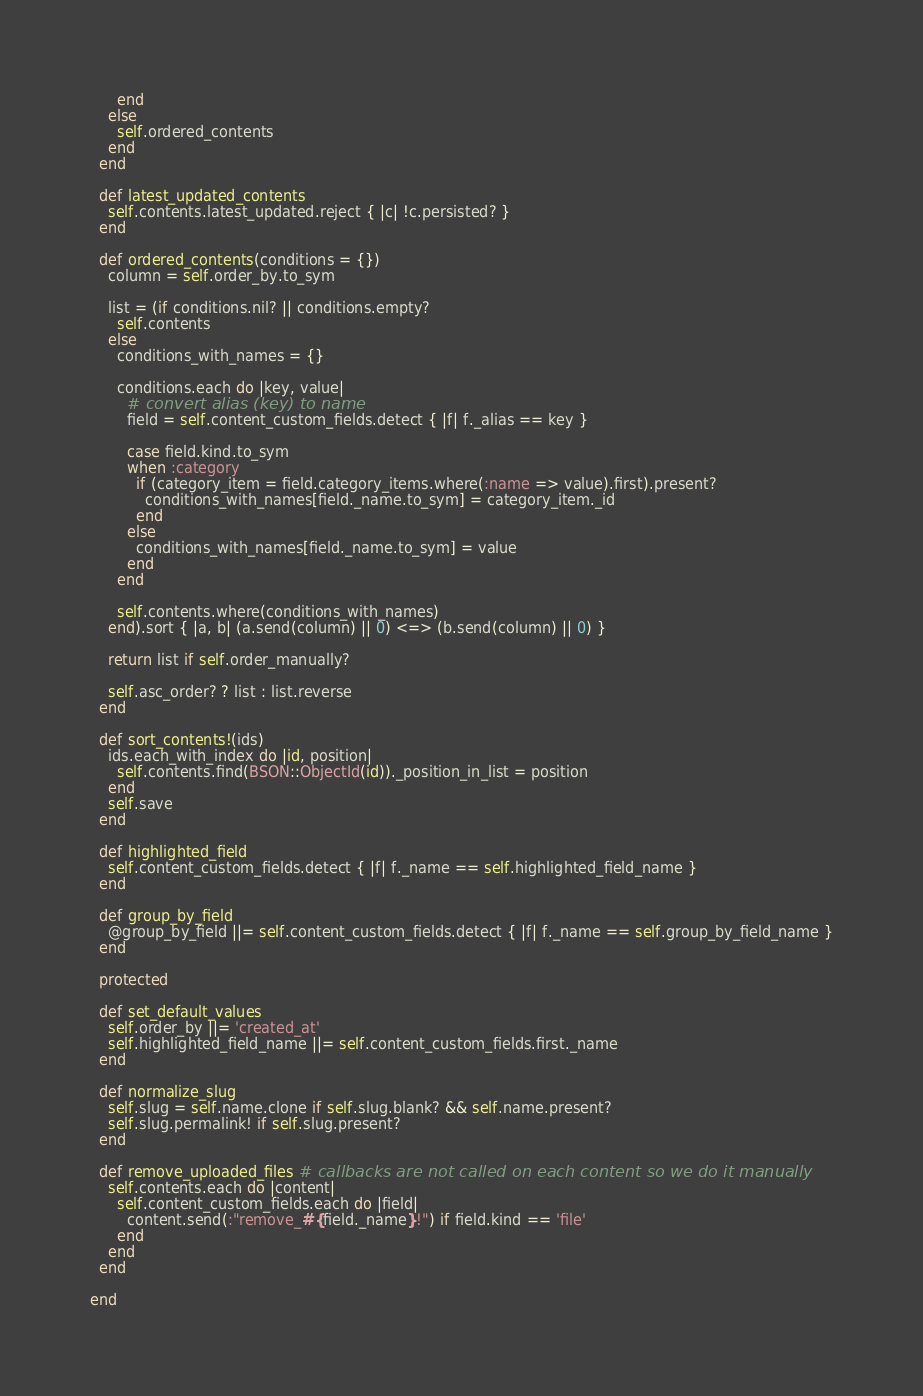<code> <loc_0><loc_0><loc_500><loc_500><_Ruby_>      end
    else
      self.ordered_contents
    end
  end

  def latest_updated_contents
    self.contents.latest_updated.reject { |c| !c.persisted? }
  end

  def ordered_contents(conditions = {})
    column = self.order_by.to_sym

    list = (if conditions.nil? || conditions.empty?
      self.contents
    else
      conditions_with_names = {}

      conditions.each do |key, value|
        # convert alias (key) to name
        field = self.content_custom_fields.detect { |f| f._alias == key }

        case field.kind.to_sym
        when :category
          if (category_item = field.category_items.where(:name => value).first).present?
            conditions_with_names[field._name.to_sym] = category_item._id
          end
        else
          conditions_with_names[field._name.to_sym] = value
        end
      end

      self.contents.where(conditions_with_names)
    end).sort { |a, b| (a.send(column) || 0) <=> (b.send(column) || 0) }

    return list if self.order_manually?

    self.asc_order? ? list : list.reverse
  end

  def sort_contents!(ids)
    ids.each_with_index do |id, position|
      self.contents.find(BSON::ObjectId(id))._position_in_list = position
    end
    self.save
  end

  def highlighted_field
    self.content_custom_fields.detect { |f| f._name == self.highlighted_field_name }
  end

  def group_by_field
    @group_by_field ||= self.content_custom_fields.detect { |f| f._name == self.group_by_field_name }
  end

  protected

  def set_default_values
    self.order_by ||= 'created_at'
    self.highlighted_field_name ||= self.content_custom_fields.first._name
  end

  def normalize_slug
    self.slug = self.name.clone if self.slug.blank? && self.name.present?
    self.slug.permalink! if self.slug.present?
  end

  def remove_uploaded_files # callbacks are not called on each content so we do it manually
    self.contents.each do |content|
      self.content_custom_fields.each do |field|
        content.send(:"remove_#{field._name}!") if field.kind == 'file'
      end
    end
  end

end
</code> 